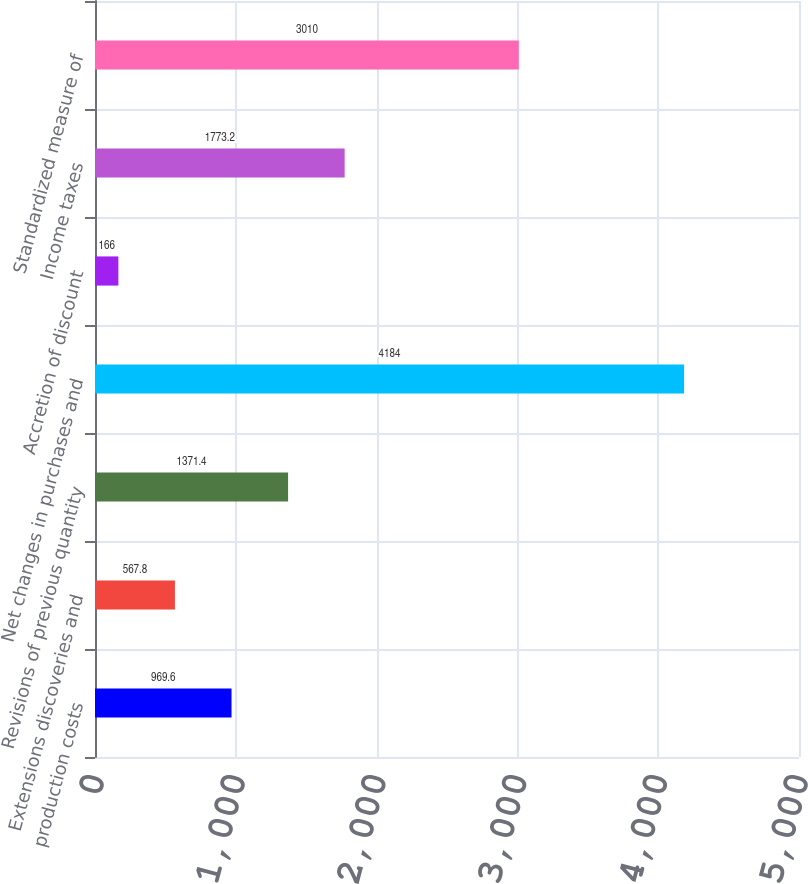<chart> <loc_0><loc_0><loc_500><loc_500><bar_chart><fcel>production costs<fcel>Extensions discoveries and<fcel>Revisions of previous quantity<fcel>Net changes in purchases and<fcel>Accretion of discount<fcel>Income taxes<fcel>Standardized measure of<nl><fcel>969.6<fcel>567.8<fcel>1371.4<fcel>4184<fcel>166<fcel>1773.2<fcel>3010<nl></chart> 